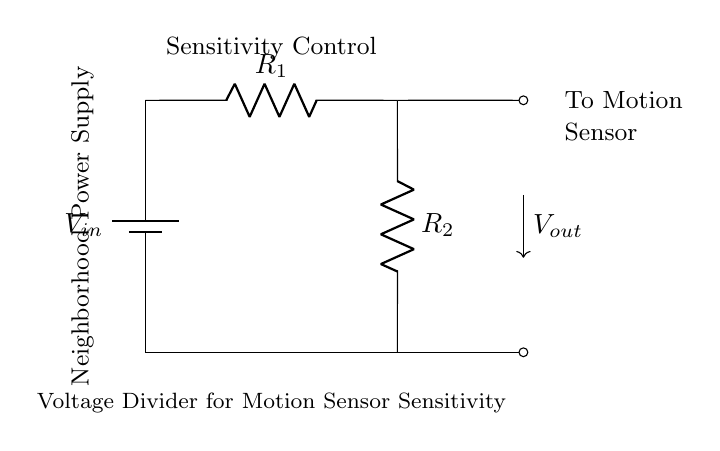What is V in this circuit? The voltage divider is powered by a battery labeled V in, which represents the input voltage in this circuit; the precise value is not provided, but it is denoted in the diagram as a generic voltage source.
Answer: Voltage in What is the purpose of R1? R1 is used as one of the resistors in the voltage divider network; it helps determine the output voltage by defining the division ratio along with R2.
Answer: Sensitivity control What is the output voltage labeled as? In the circuit diagram, the output voltage is labeled as V out, indicating the voltage that can be taken from the node between R1 and R2 for controlling the motion sensor sensitivity.
Answer: V out What can the output voltage (V out) be used for? V out can be used to provide a controlled voltage to adjust the sensitivity of the motion sensor, allowing for fine-tuning of the sensor’s responsiveness based on external conditions.
Answer: To motion sensor What happens to V out when R2 is increased? If R2 is increased, the output voltage V out will typically decrease, as the voltage divider formula shows that a larger R2 relative to R1 lowers the output voltage, effective for fine-tuning sensitivity.
Answer: Decreases What does the circuit represent in practical terms? This circuit diagram represents a voltage divider used in a neighborhood watch program for controlling the sensitivity of motion sensors, which are crucial for effectively monitoring and detecting movement in an area.
Answer: Neighborhood watch program 